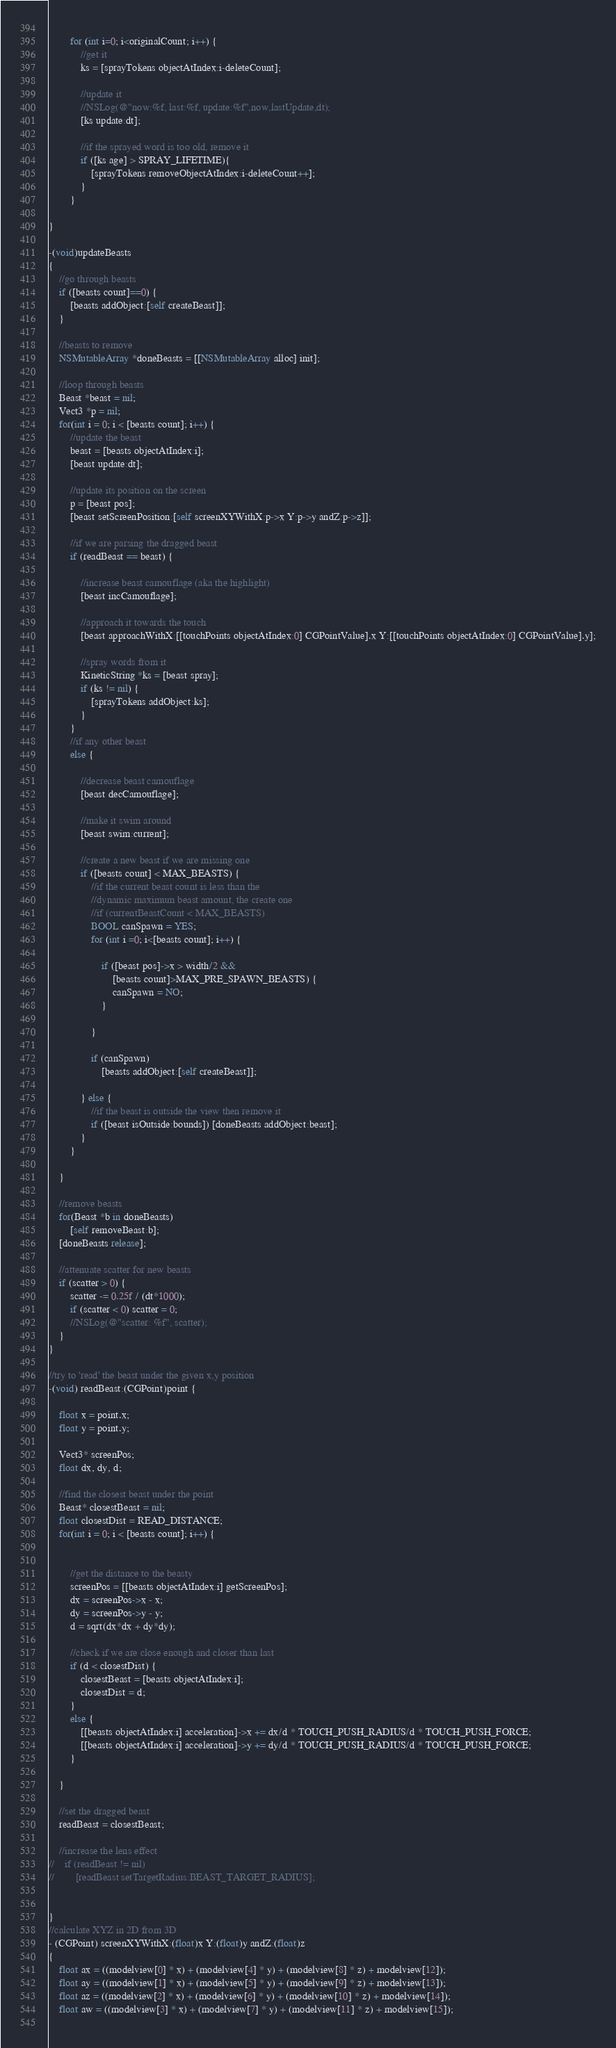<code> <loc_0><loc_0><loc_500><loc_500><_ObjectiveC_>        
        for (int i=0; i<originalCount; i++) {
            //get it
            ks = [sprayTokens objectAtIndex:i-deleteCount];
            
            //update it
            //NSLog(@"now:%f, last:%f, update:%f",now,lastUpdate,dt);
            [ks update:dt];
            
            //if the sprayed word is too old, remove it
            if ([ks age] > SPRAY_LIFETIME){
                [sprayTokens removeObjectAtIndex:i-deleteCount++];
            }
        }
      
}

-(void)updateBeasts
{
    //go through beasts
    if ([beasts count]==0) {
        [beasts addObject:[self createBeast]];
    }
    
    //beasts to remove
    NSMutableArray *doneBeasts = [[NSMutableArray alloc] init];
    
    //loop through beasts
    Beast *beast = nil;
    Vect3 *p = nil;
    for(int i = 0; i < [beasts count]; i++) {          
        //update the beast    
        beast = [beasts objectAtIndex:i];
        [beast update:dt];
        
        //update its position on the screen    
        p = [beast pos];
        [beast setScreenPosition:[self screenXYWithX:p->x Y:p->y andZ:p->z]];
        
        //if we are parsing the dragged beast
        if (readBeast == beast) {
           
            //increase beast camouflage (aka the highlight)
            [beast incCamouflage];
            
            //approach it towards the touch
            [beast approachWithX:[[touchPoints objectAtIndex:0] CGPointValue].x Y:[[touchPoints objectAtIndex:0] CGPointValue].y];
            
            //spray words from it
            KineticString *ks = [beast spray];
            if (ks != nil) {
                [sprayTokens addObject:ks];  
            }
        }
        //if any other beast
        else {
            
            //decrease beast camouflage
            [beast decCamouflage];
            
            //make it swim around
            [beast swim:current];
            
            //create a new beast if we are missing one
            if ([beasts count] < MAX_BEASTS) {
                //if the current beast count is less than the
                //dynamic maximum beast amount, the create one
                //if (currentBeastCount < MAX_BEASTS)
                BOOL canSpawn = YES;
                for (int i =0; i<[beasts count]; i++) {
                    
                    if ([beast pos]->x > width/2 &&
                        [beasts count]>MAX_PRE_SPAWN_BEASTS) {
                        canSpawn = NO;
                    }
                    
                }
                
                if (canSpawn)
                    [beasts addObject:[self createBeast]];                    

            } else {                 
                //if the beast is outside the view then remove it
                if ([beast isOutside:bounds]) [doneBeasts addObject:beast];
            }
        }    
        
    }
 
    //remove beasts
    for(Beast *b in doneBeasts)
        [self removeBeast:b];
    [doneBeasts release];
    
    //attenuate scatter for new beasts
    if (scatter > 0) {
        scatter -= 0.25f / (dt*1000);
        if (scatter < 0) scatter = 0;
        //NSLog(@"scatter: %f", scatter);
    }
}

//try to 'read' the beast under the given x,y position
-(void) readBeast:(CGPoint)point {
    
    float x = point.x;
    float y = point.y;
    
    Vect3* screenPos;
    float dx, dy, d;
    
    //find the closest beast under the point
    Beast* closestBeast = nil;
    float closestDist = READ_DISTANCE;
    for(int i = 0; i < [beasts count]; i++) {

        
        //get the distance to the beasty
        screenPos = [[beasts objectAtIndex:i] getScreenPos];
        dx = screenPos->x - x;
        dy = screenPos->y - y;
        d = sqrt(dx*dx + dy*dy);
        
        //check if we are close enough and closer than last
        if (d < closestDist) {
            closestBeast = [beasts objectAtIndex:i];
            closestDist = d;
        }
        else {
            [[beasts objectAtIndex:i] acceleration]->x += dx/d * TOUCH_PUSH_RADIUS/d * TOUCH_PUSH_FORCE;
            [[beasts objectAtIndex:i] acceleration]->y += dy/d * TOUCH_PUSH_RADIUS/d * TOUCH_PUSH_FORCE;
        }
        
    }
    
    //set the dragged beast
    readBeast = closestBeast;
    
    //increase the lens effect
//    if (readBeast != nil)
//        [readBeast setTargetRadius:BEAST_TARGET_RADIUS];
    

}
//calculate XYZ in 2D from 3D
- (CGPoint) screenXYWithX:(float)x Y:(float)y andZ:(float)z
{
	float ax = ((modelview[0] * x) + (modelview[4] * y) + (modelview[8] * z) + modelview[12]);
	float ay = ((modelview[1] * x) + (modelview[5] * y) + (modelview[9] * z) + modelview[13]);
	float az = ((modelview[2] * x) + (modelview[6] * y) + (modelview[10] * z) + modelview[14]);
	float aw = ((modelview[3] * x) + (modelview[7] * y) + (modelview[11] * z) + modelview[15]);
	</code> 